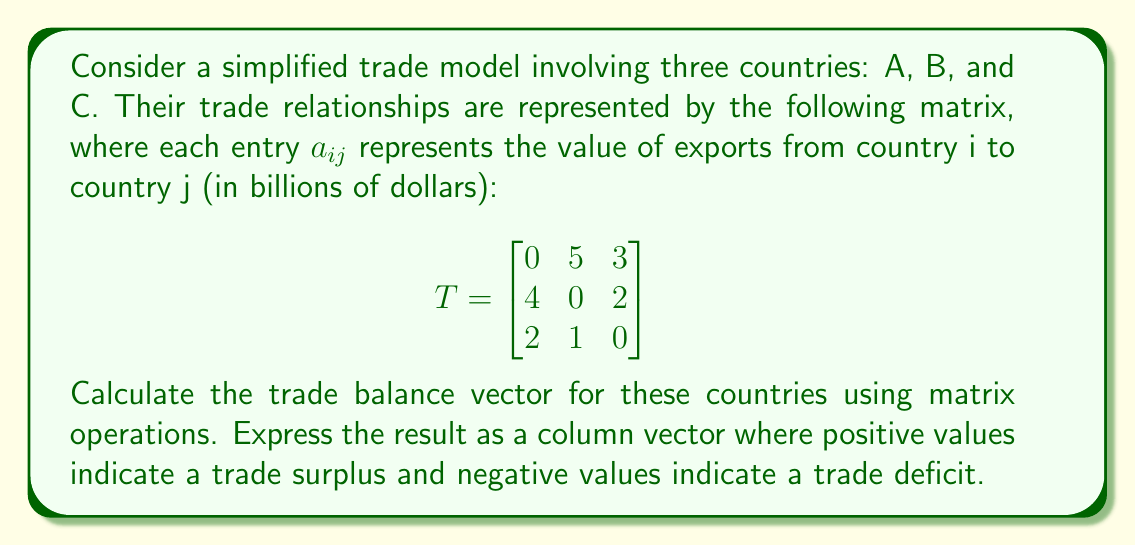Solve this math problem. To calculate the trade balance vector, we need to follow these steps:

1) First, we need to understand what the trade balance represents. For each country, it's the difference between its total exports and total imports.

2) To find the total exports for each country, we sum the rows of the matrix T:

   Country A exports: $5 + 3 = 8$
   Country B exports: $4 + 2 = 6$
   Country C exports: $2 + 1 = 3$

3) To find the total imports for each country, we sum the columns of the matrix T:

   Country A imports: $4 + 2 = 6$
   Country B imports: $5 + 1 = 6$
   Country C imports: $3 + 2 = 5$

4) We can represent these operations using matrix multiplication:

   Exports vector: $E = T \cdot \mathbf{1}$, where $\mathbf{1}$ is a column vector of ones.
   Imports vector: $I = T^T \cdot \mathbf{1}$, where $T^T$ is the transpose of T.

5) The trade balance is then $B = E - I$:

   $$
   B = T \cdot \mathbf{1} - T^T \cdot \mathbf{1} = (T - T^T) \cdot \mathbf{1}
   $$

6) Let's calculate $T - T^T$:

   $$
   T - T^T = \begin{bmatrix}
   0 & 5 & 3 \\
   4 & 0 & 2 \\
   2 & 1 & 0
   \end{bmatrix} - 
   \begin{bmatrix}
   0 & 4 & 2 \\
   5 & 0 & 1 \\
   3 & 2 & 0
   \end{bmatrix} =
   \begin{bmatrix}
   0 & 1 & 1 \\
   -1 & 0 & 1 \\
   -1 & -1 & 0
   \end{bmatrix}
   $$

7) Now, we multiply this result by the column vector of ones:

   $$
   B = (T - T^T) \cdot \mathbf{1} = 
   \begin{bmatrix}
   0 & 1 & 1 \\
   -1 & 0 & 1 \\
   -1 & -1 & 0
   \end{bmatrix} \cdot
   \begin{bmatrix}
   1 \\
   1 \\
   1
   \end{bmatrix} =
   \begin{bmatrix}
   2 \\
   0 \\
   -2
   \end{bmatrix}
   $$

This result shows that Country A has a trade surplus of 2 billion dollars, Country B has a balanced trade, and Country C has a trade deficit of 2 billion dollars.
Answer: $$
\begin{bmatrix}
2 \\
0 \\
-2
\end{bmatrix}
$$ 